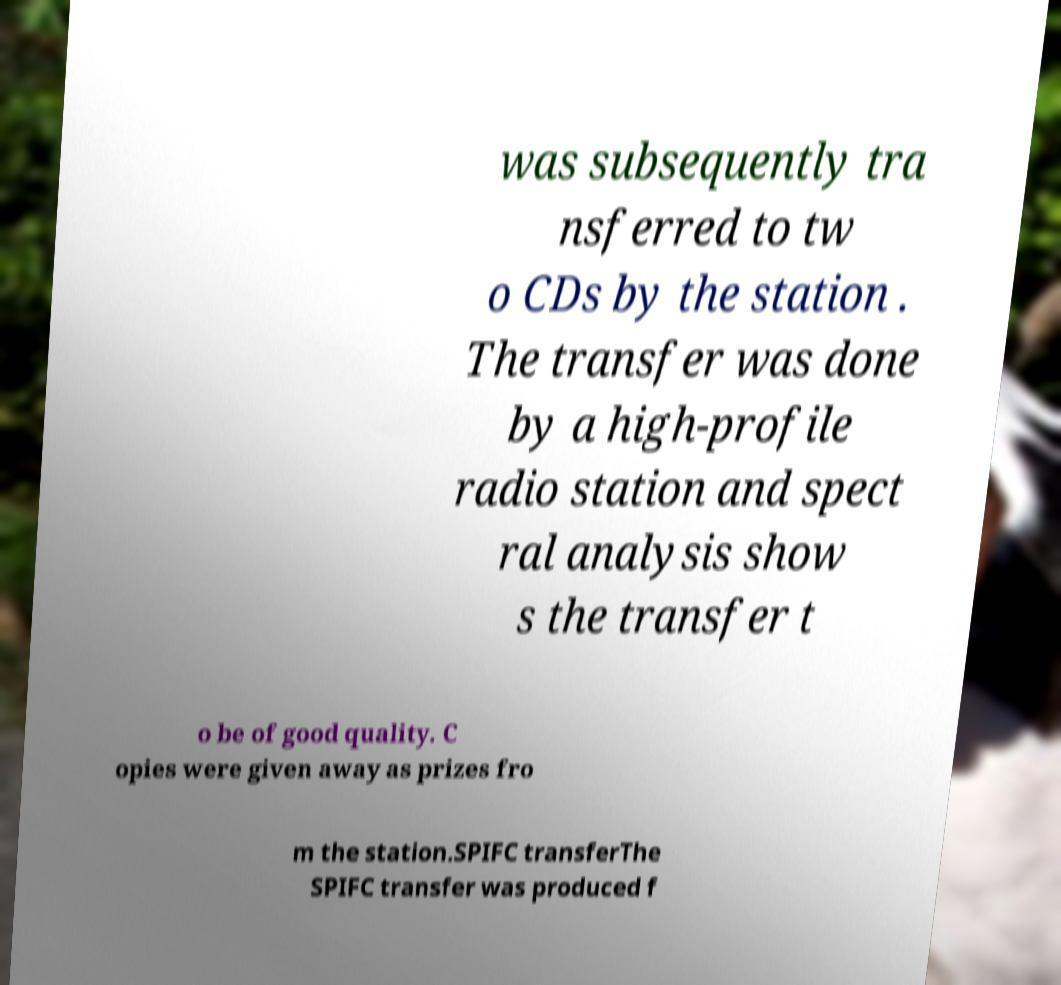What messages or text are displayed in this image? I need them in a readable, typed format. was subsequently tra nsferred to tw o CDs by the station . The transfer was done by a high-profile radio station and spect ral analysis show s the transfer t o be of good quality. C opies were given away as prizes fro m the station.SPIFC transferThe SPIFC transfer was produced f 